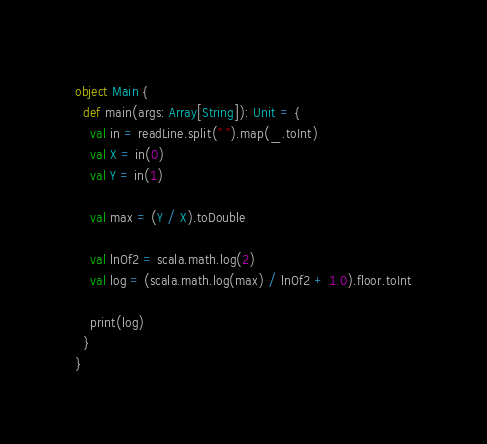Convert code to text. <code><loc_0><loc_0><loc_500><loc_500><_Scala_>object Main {
  def main(args: Array[String]): Unit = {
    val in = readLine.split(" ").map(_.toInt)
    val X = in(0)
    val Y = in(1)

    val max = (Y / X).toDouble
    
    val lnOf2 = scala.math.log(2)
    val log = (scala.math.log(max) / lnOf2 + 1.0).floor.toInt

    print(log)
  }
}</code> 